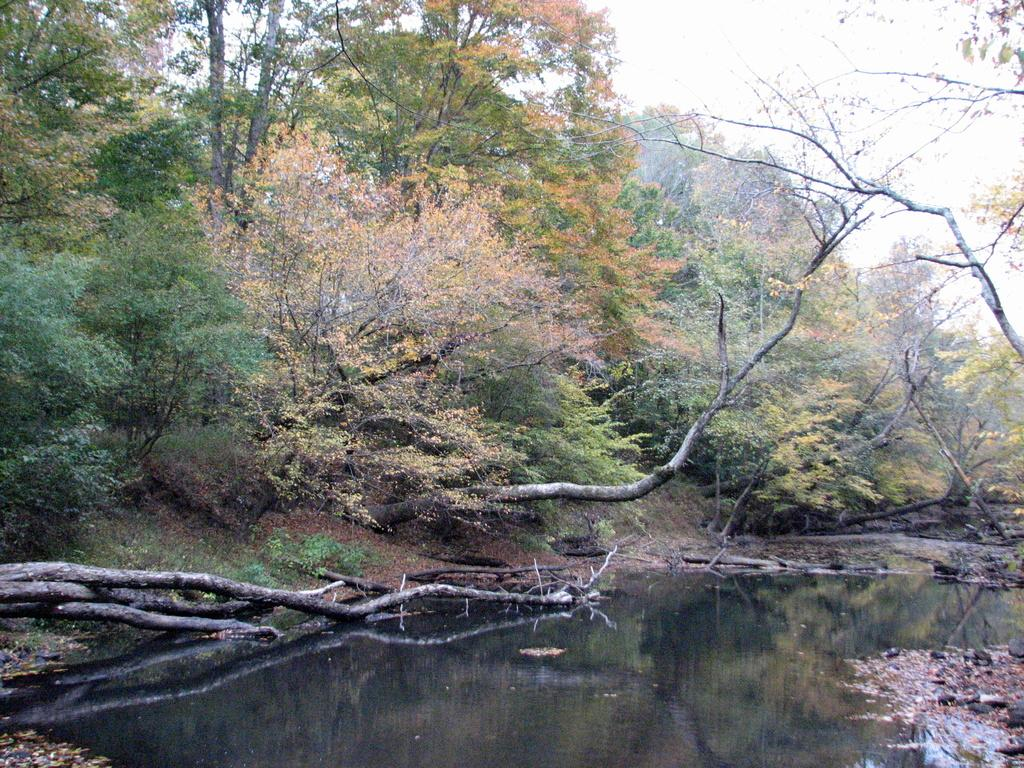What is located in front of the image? There is water in front of the image. What can be seen on the branches of the tree? The branches of a tree are visible in the image. What type of natural formation is present in the image? Rocks are present in the image. What is visible in the background of the image? There are trees in the background of the image. What is visible at the top of the image? The sky is visible at the top of the image. Can you see anyone's feet in the image? There are no feet visible in the image. Is there a car driving through the water in the image? There is no car or driving activity present in the image. 